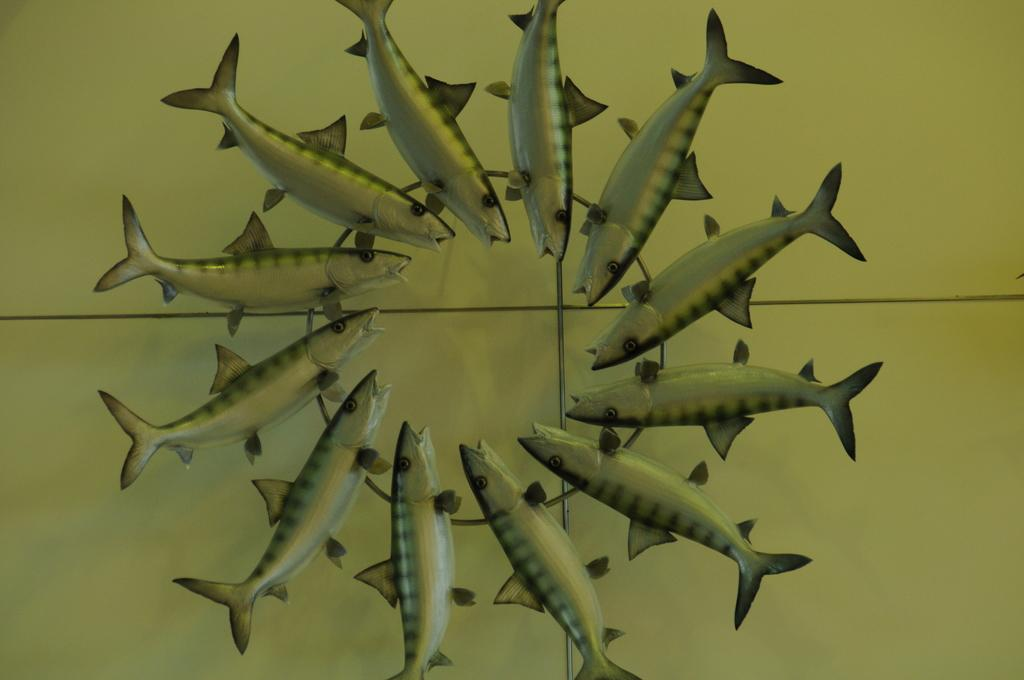What type of animals can be seen in the picture? There are fishes in the picture. Where are the fishes located in the image? The fishes are placed on a surface. What body parts do the fishes have? The fishes have tails, fins, eyes, and mouths. What type of meat can be seen hanging from the plough in the image? There is no plough or meat present in the image; it features fishes on a surface. 